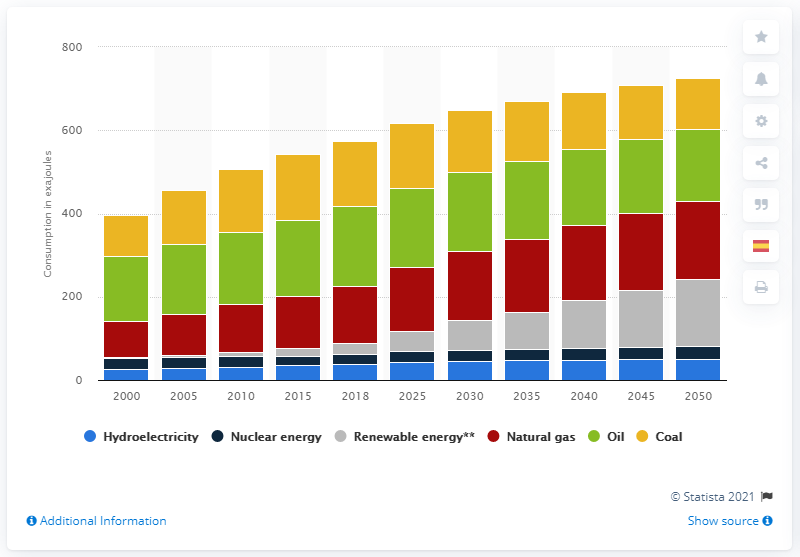Point out several critical features in this image. By 2050, renewable energy consumption is projected to reach 161 exajoules. It is expected that renewable energy consumption will increase significantly by the year 2050. 